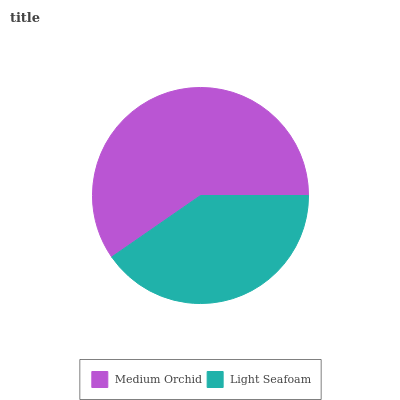Is Light Seafoam the minimum?
Answer yes or no. Yes. Is Medium Orchid the maximum?
Answer yes or no. Yes. Is Light Seafoam the maximum?
Answer yes or no. No. Is Medium Orchid greater than Light Seafoam?
Answer yes or no. Yes. Is Light Seafoam less than Medium Orchid?
Answer yes or no. Yes. Is Light Seafoam greater than Medium Orchid?
Answer yes or no. No. Is Medium Orchid less than Light Seafoam?
Answer yes or no. No. Is Medium Orchid the high median?
Answer yes or no. Yes. Is Light Seafoam the low median?
Answer yes or no. Yes. Is Light Seafoam the high median?
Answer yes or no. No. Is Medium Orchid the low median?
Answer yes or no. No. 